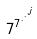<formula> <loc_0><loc_0><loc_500><loc_500>7 ^ { 7 ^ { \cdot ^ { \cdot ^ { \cdot ^ { j } } } } }</formula> 